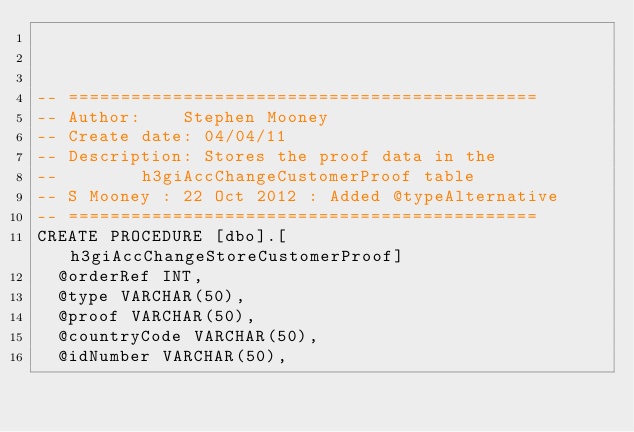Convert code to text. <code><loc_0><loc_0><loc_500><loc_500><_SQL_>


-- =============================================
-- Author:		Stephen Mooney 
-- Create date: 04/04/11
-- Description:	Stores the proof data in the 
--				h3giAccChangeCustomerProof table
-- S Mooney : 22 Oct 2012 : Added @typeAlternative
-- =============================================
CREATE PROCEDURE [dbo].[h3giAccChangeStoreCustomerProof] 
	@orderRef INT,
	@type VARCHAR(50),
	@proof VARCHAR(50),
	@countryCode VARCHAR(50),
	@idNumber VARCHAR(50),</code> 